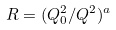Convert formula to latex. <formula><loc_0><loc_0><loc_500><loc_500>R = ( Q _ { 0 } ^ { 2 } / Q ^ { 2 } ) ^ { a }</formula> 